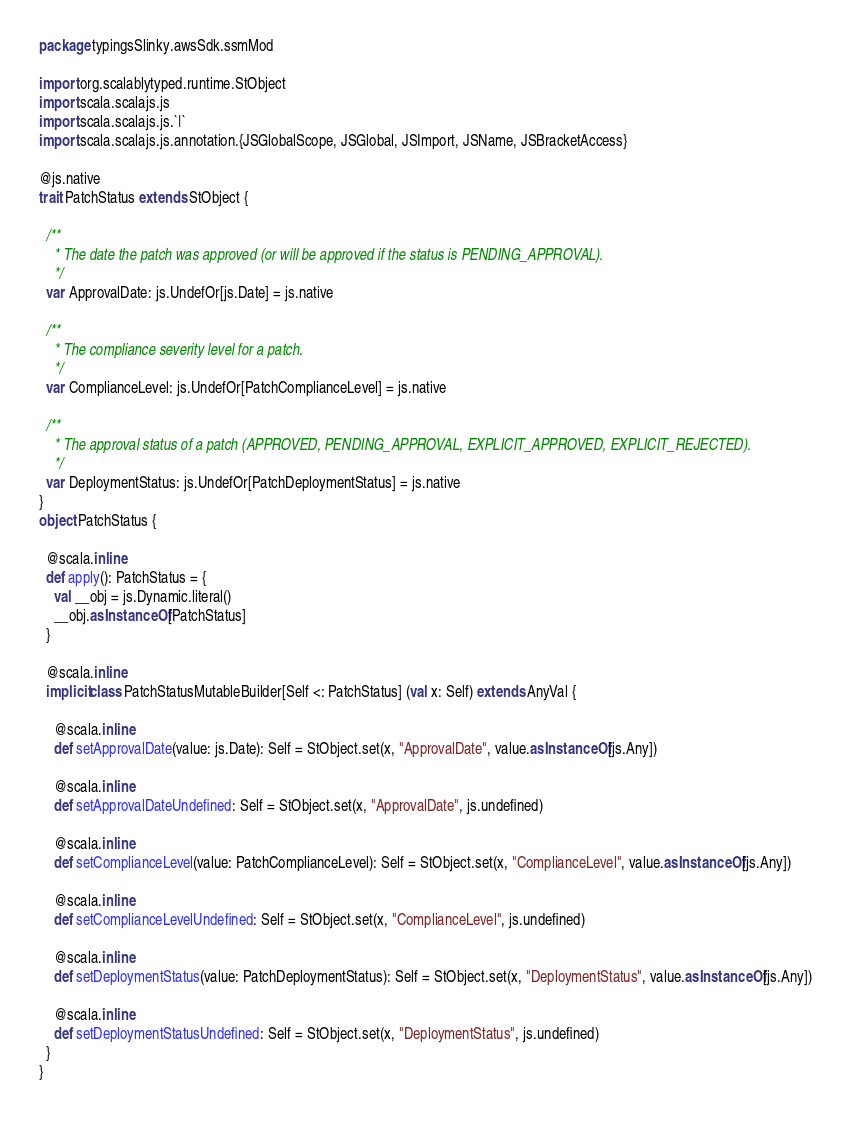Convert code to text. <code><loc_0><loc_0><loc_500><loc_500><_Scala_>package typingsSlinky.awsSdk.ssmMod

import org.scalablytyped.runtime.StObject
import scala.scalajs.js
import scala.scalajs.js.`|`
import scala.scalajs.js.annotation.{JSGlobalScope, JSGlobal, JSImport, JSName, JSBracketAccess}

@js.native
trait PatchStatus extends StObject {
  
  /**
    * The date the patch was approved (or will be approved if the status is PENDING_APPROVAL).
    */
  var ApprovalDate: js.UndefOr[js.Date] = js.native
  
  /**
    * The compliance severity level for a patch.
    */
  var ComplianceLevel: js.UndefOr[PatchComplianceLevel] = js.native
  
  /**
    * The approval status of a patch (APPROVED, PENDING_APPROVAL, EXPLICIT_APPROVED, EXPLICIT_REJECTED).
    */
  var DeploymentStatus: js.UndefOr[PatchDeploymentStatus] = js.native
}
object PatchStatus {
  
  @scala.inline
  def apply(): PatchStatus = {
    val __obj = js.Dynamic.literal()
    __obj.asInstanceOf[PatchStatus]
  }
  
  @scala.inline
  implicit class PatchStatusMutableBuilder[Self <: PatchStatus] (val x: Self) extends AnyVal {
    
    @scala.inline
    def setApprovalDate(value: js.Date): Self = StObject.set(x, "ApprovalDate", value.asInstanceOf[js.Any])
    
    @scala.inline
    def setApprovalDateUndefined: Self = StObject.set(x, "ApprovalDate", js.undefined)
    
    @scala.inline
    def setComplianceLevel(value: PatchComplianceLevel): Self = StObject.set(x, "ComplianceLevel", value.asInstanceOf[js.Any])
    
    @scala.inline
    def setComplianceLevelUndefined: Self = StObject.set(x, "ComplianceLevel", js.undefined)
    
    @scala.inline
    def setDeploymentStatus(value: PatchDeploymentStatus): Self = StObject.set(x, "DeploymentStatus", value.asInstanceOf[js.Any])
    
    @scala.inline
    def setDeploymentStatusUndefined: Self = StObject.set(x, "DeploymentStatus", js.undefined)
  }
}
</code> 